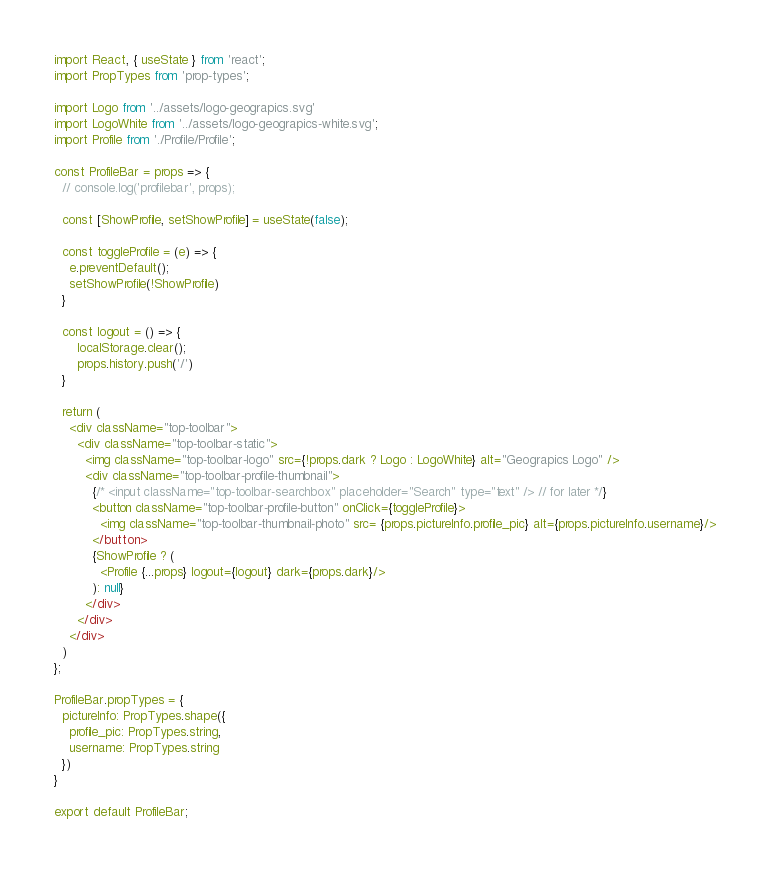Convert code to text. <code><loc_0><loc_0><loc_500><loc_500><_JavaScript_>import React, { useState } from 'react';
import PropTypes from 'prop-types';

import Logo from '../assets/logo-geograpics.svg'
import LogoWhite from '../assets/logo-geograpics-white.svg';
import Profile from './Profile/Profile';

const ProfileBar = props => {
  // console.log('profilebar', props);

  const [ShowProfile, setShowProfile] = useState(false);

  const toggleProfile = (e) => {
    e.preventDefault();
    setShowProfile(!ShowProfile)
  }

  const logout = () => {
      localStorage.clear();
      props.history.push('/') 
  }

  return (
    <div className="top-toolbar">
      <div className="top-toolbar-static">
        <img className="top-toolbar-logo" src={!props.dark ? Logo : LogoWhite} alt="Geograpics Logo" />
        <div className="top-toolbar-profile-thumbnail">
          {/* <input className="top-toolbar-searchbox" placeholder="Search" type="text" /> // for later */}
          <button className="top-toolbar-profile-button" onClick={toggleProfile}>
            <img className="top-toolbar-thumbnail-photo" src= {props.pictureInfo.profile_pic} alt={props.pictureInfo.username}/>
          </button>
          {ShowProfile ? (
            <Profile {...props} logout={logout} dark={props.dark}/>
          ): null}
        </div>
      </div>
    </div>
  )
};

ProfileBar.propTypes = {
  pictureInfo: PropTypes.shape({
    profile_pic: PropTypes.string,
    username: PropTypes.string
  })
}

export default ProfileBar;</code> 